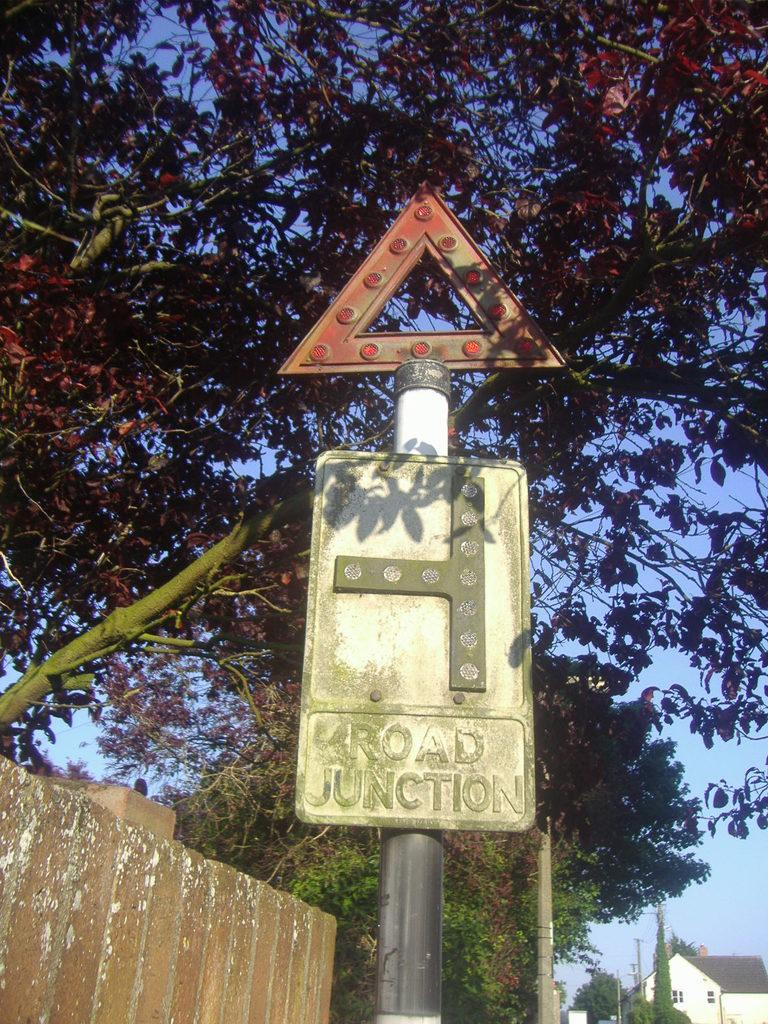What type of structure is visible in the image? There is a house in the image. What other objects can be seen in the image? There are poles and boards with poles visible in the image. What is located on the left side of the image? There is a wall on the left side of the image. What type of vegetation is present in the image? There are trees on the ground in the image. What is visible in the background of the image? The sky is visible in the background of the image. How many dimes can be seen on the wall in the image? There are no dimes present on the wall in the image. What type of pump is connected to the poles in the image? There is no pump connected to the poles in the image. 